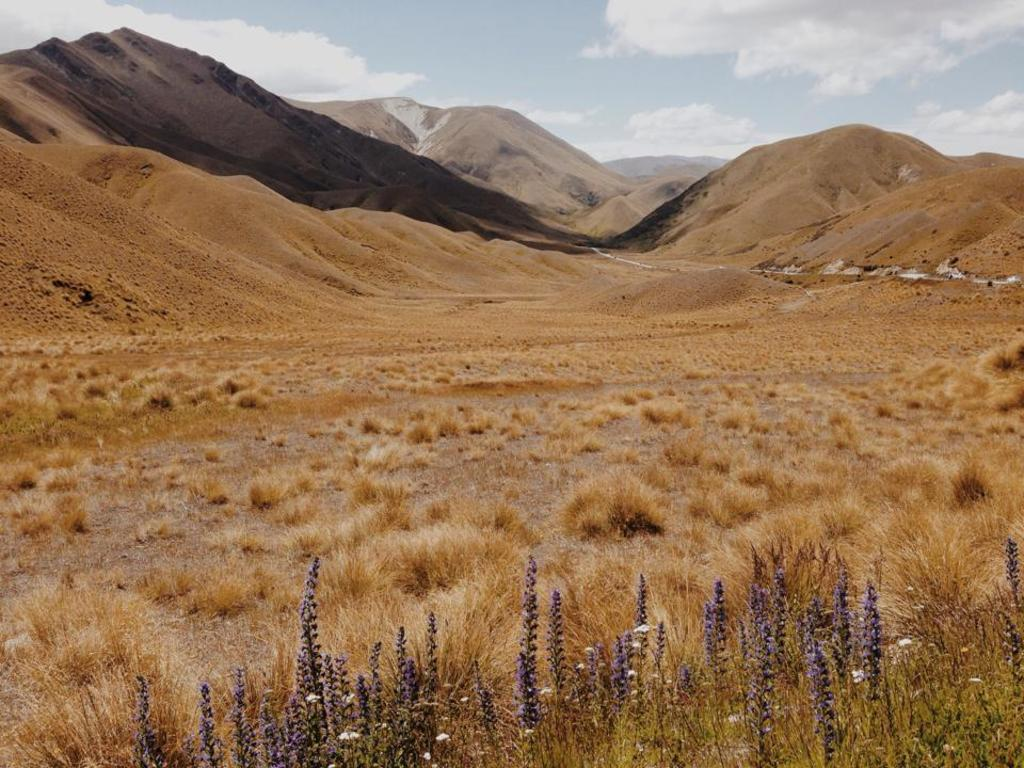What type of vegetation can be seen in the image? There are plants in the image. What is the terrain like in the image? There is a grassy land in the image. What geographical feature is located in the middle of the image? Mountains are present in the middle of the image. What is visible in the background of the image? The sky is visible in the background of the image. What is the weather like in the image? The sky is cloudy in the image. What type of nerve can be seen in the image? There is no nerve present in the image; it features plants, grassy land, mountains, and a cloudy sky. 